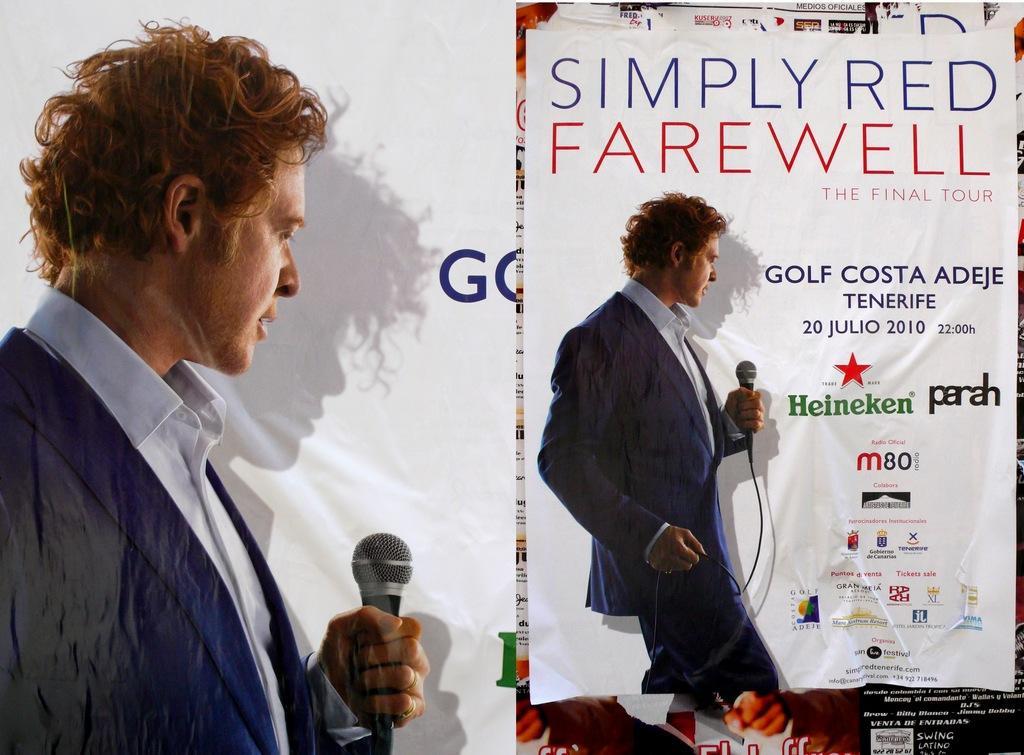Can you describe this image briefly? in the picture we can see a poster,on the poster we can see a person holding a microphone and standing. 